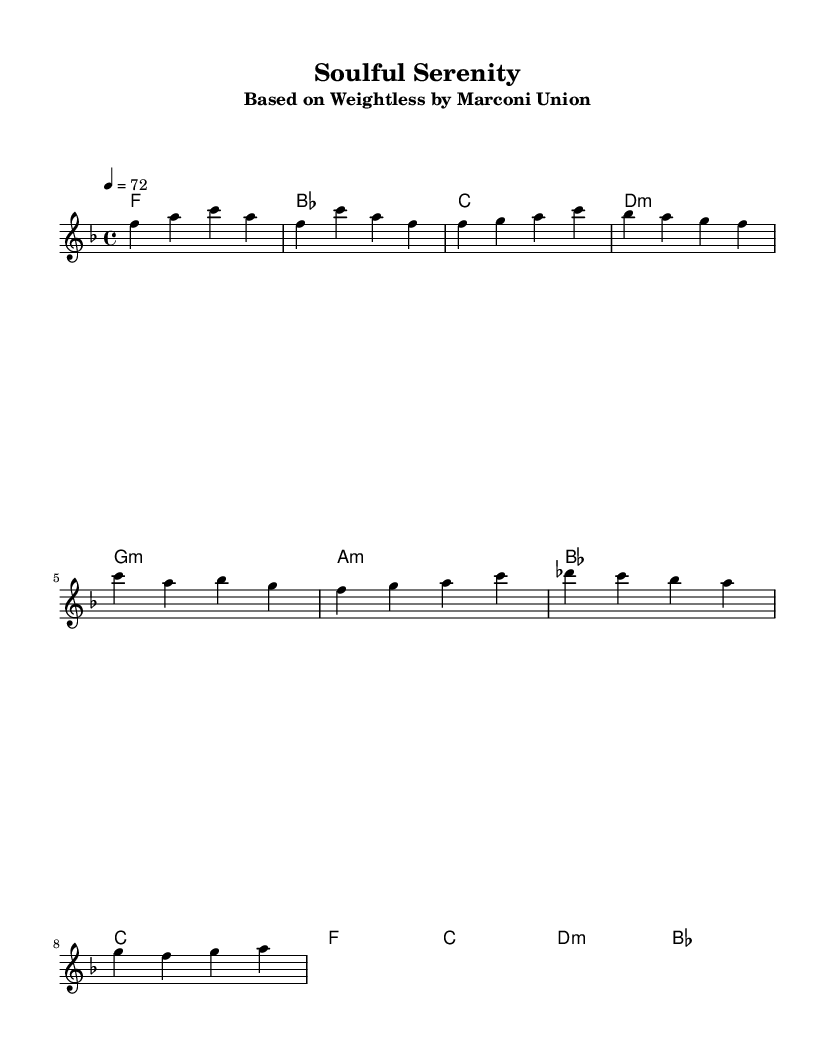What is the key signature of this music? The key signature is F major, as indicated by the presence of one flat (B flat) on the staff.
Answer: F major What is the time signature of this piece? The time signature is 4/4, which is shown at the beginning of the score with the notation "4/4" written next to the clef.
Answer: 4/4 What is the tempo marking for this music? The tempo marking is 72 beats per minute, indicated by the notation "4 = 72" at the start of the score.
Answer: 72 How many measures are in the chorus section? The chorus section consists of two measures, as indicated by the musical notation which shows two lines of melody corresponding to the chorus.
Answer: 2 What is the type of the bridge harmonies? The bridge features a mix of major and minor harmonies; specifically, the first and last chords of the bridge section are major while the middle ones are minor.
Answer: Major and minor What does the title "Soulful Serenity" suggest about the character of the music? The title suggests a calming and peaceful nature, typical of soulful songs that aim to evoke relaxation and tranquility, consistent with therapist recommendations for relaxation.
Answer: Calming Which instrument is indicated to play the melody? The melody is indicated to be played by a voice, as designated by the label "Voice = 'melody'" in the score's staff notation.
Answer: Voice 